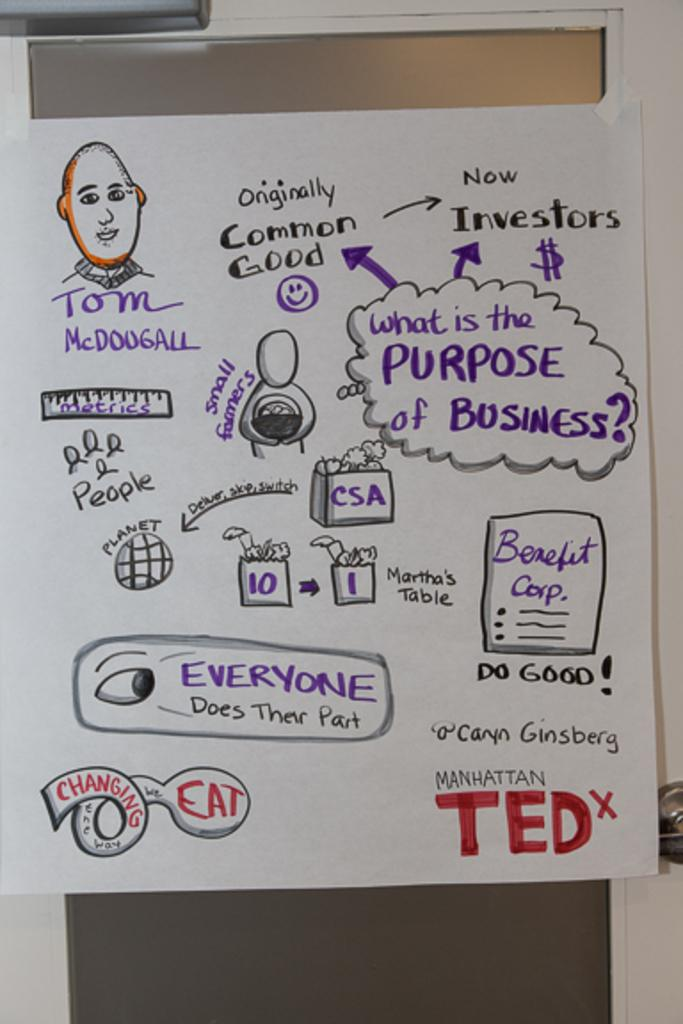What is present on the door in the image? There is a poster on the door in the image. What is depicted on the poster? The poster contains drawings and text. What color is the wall surrounding the door? The wall is painted white. What type of engine is visible in the image? There is no engine present in the image; it features a poster on a door with drawings and text. Can you tell me how many people are lifting the poster in the image? There are no people lifting the poster in the image; it is attached to the door. 